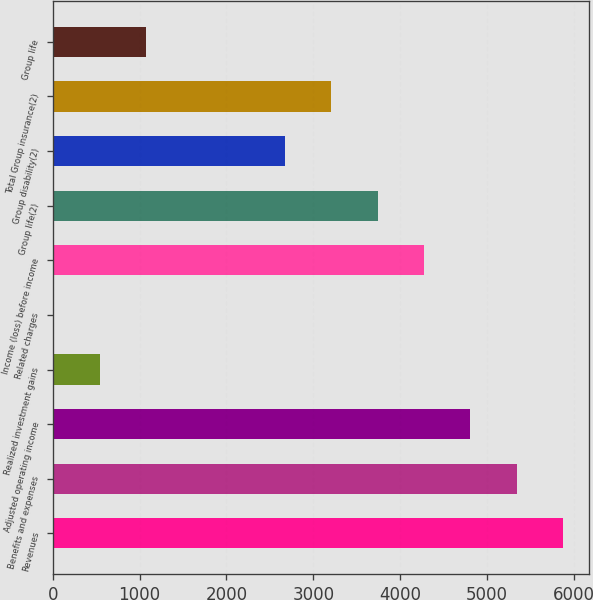<chart> <loc_0><loc_0><loc_500><loc_500><bar_chart><fcel>Revenues<fcel>Benefits and expenses<fcel>Adjusted operating income<fcel>Realized investment gains<fcel>Related charges<fcel>Income (loss) before income<fcel>Group life(2)<fcel>Group disability(2)<fcel>Total Group insurance(2)<fcel>Group life<nl><fcel>5876.7<fcel>5343<fcel>4809.3<fcel>539.7<fcel>6<fcel>4275.6<fcel>3741.9<fcel>2674.5<fcel>3208.2<fcel>1073.4<nl></chart> 